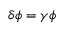Convert formula to latex. <formula><loc_0><loc_0><loc_500><loc_500>\delta \phi = \gamma \phi</formula> 